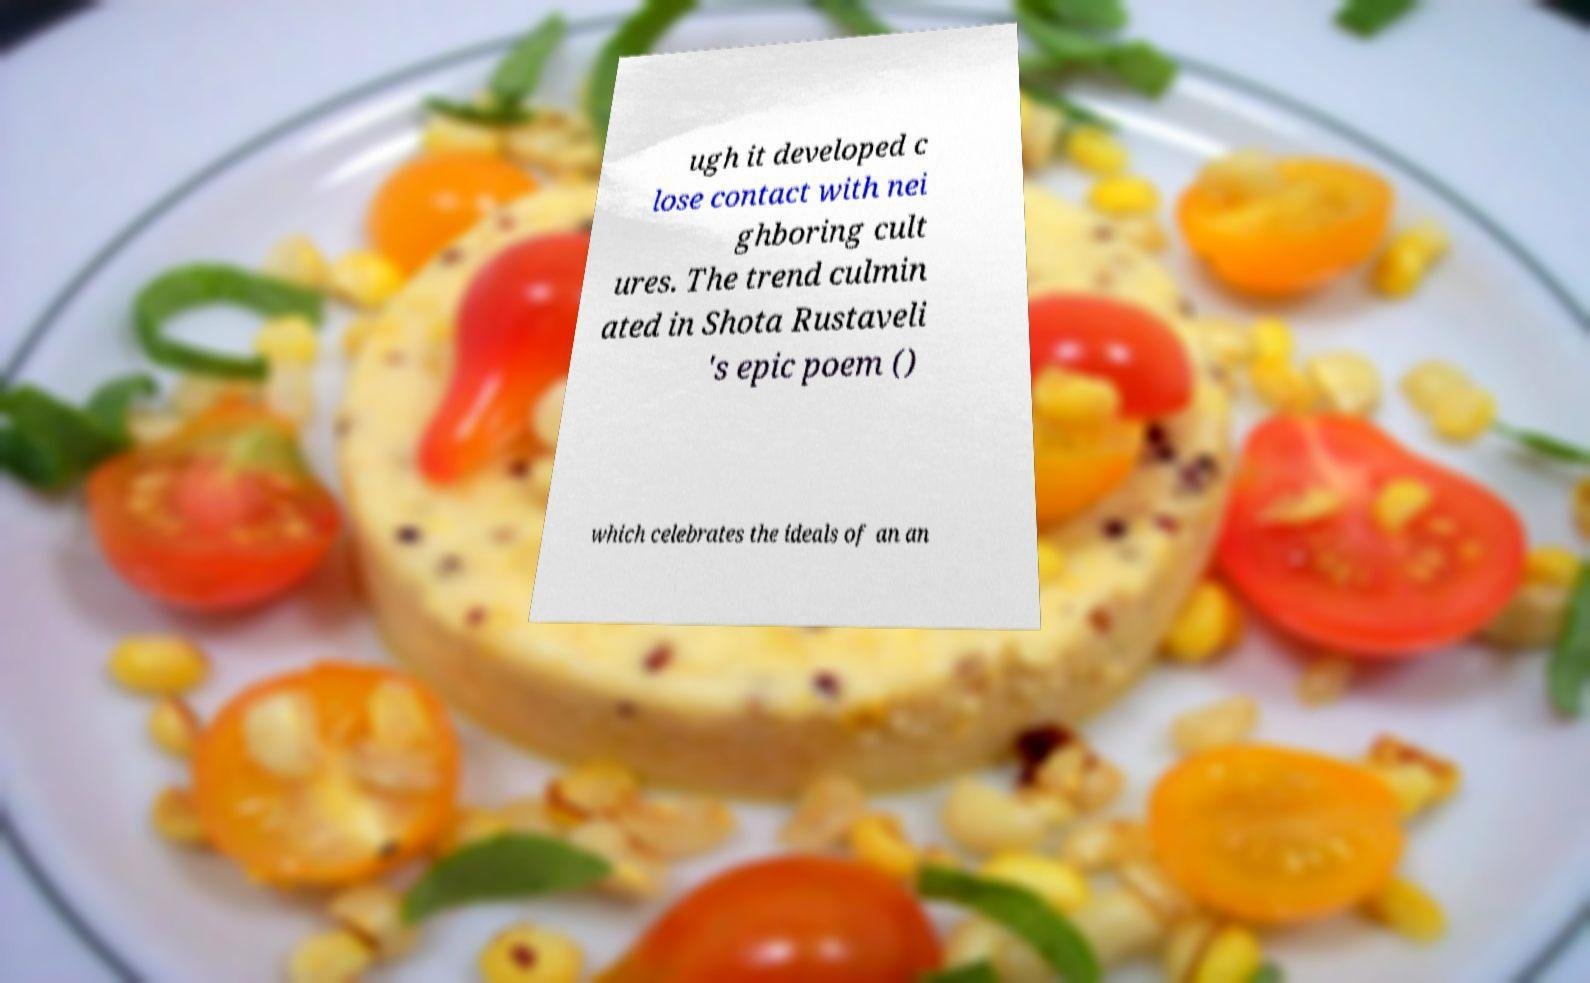For documentation purposes, I need the text within this image transcribed. Could you provide that? ugh it developed c lose contact with nei ghboring cult ures. The trend culmin ated in Shota Rustaveli 's epic poem () which celebrates the ideals of an an 